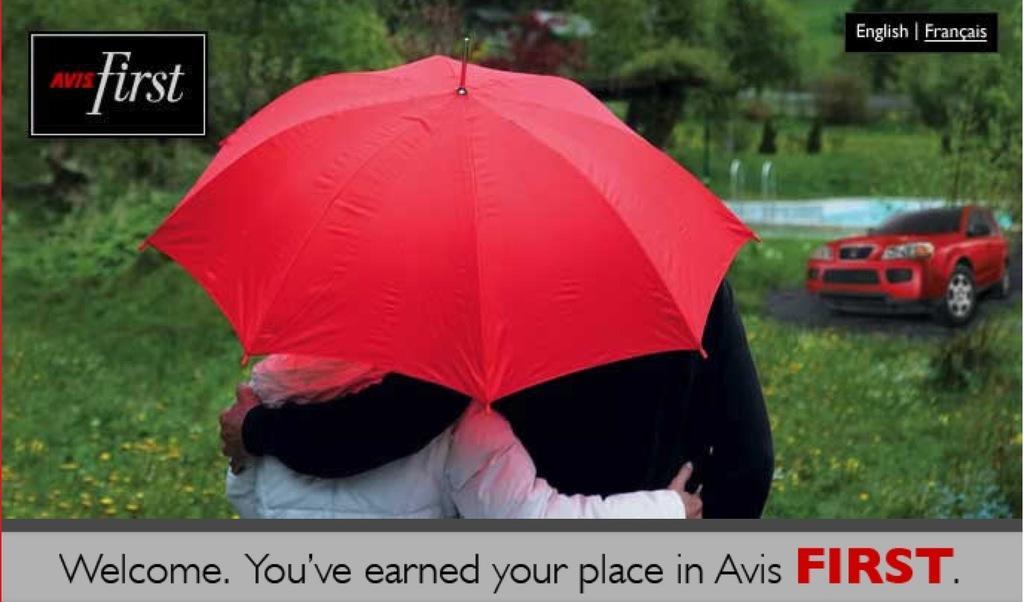In one or two sentences, can you explain what this image depicts? There are two people holding each other and we can see red color umbrella. Background we can see car,plants and trees. Top and bottom of the image we can see text. 